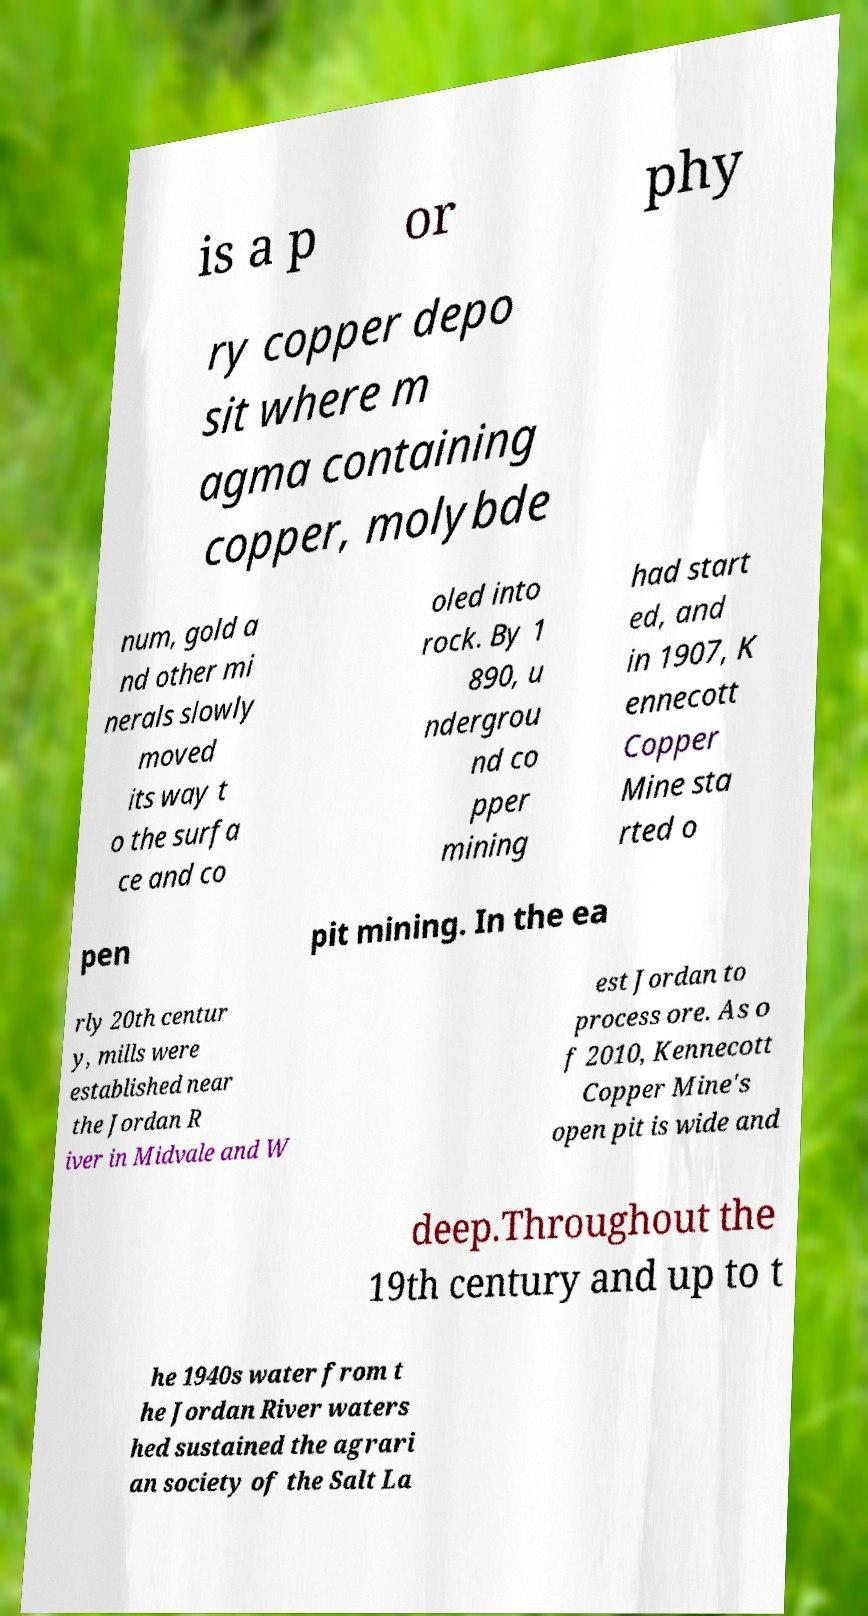I need the written content from this picture converted into text. Can you do that? is a p or phy ry copper depo sit where m agma containing copper, molybde num, gold a nd other mi nerals slowly moved its way t o the surfa ce and co oled into rock. By 1 890, u ndergrou nd co pper mining had start ed, and in 1907, K ennecott Copper Mine sta rted o pen pit mining. In the ea rly 20th centur y, mills were established near the Jordan R iver in Midvale and W est Jordan to process ore. As o f 2010, Kennecott Copper Mine's open pit is wide and deep.Throughout the 19th century and up to t he 1940s water from t he Jordan River waters hed sustained the agrari an society of the Salt La 